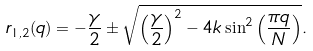Convert formula to latex. <formula><loc_0><loc_0><loc_500><loc_500>r _ { 1 , 2 } ( q ) = - \frac { \gamma } { 2 } \pm \sqrt { \left ( \frac { \gamma } { 2 } \right ) ^ { 2 } - 4 k \sin ^ { 2 } \left ( \frac { \pi q } { N } \right ) } .</formula> 